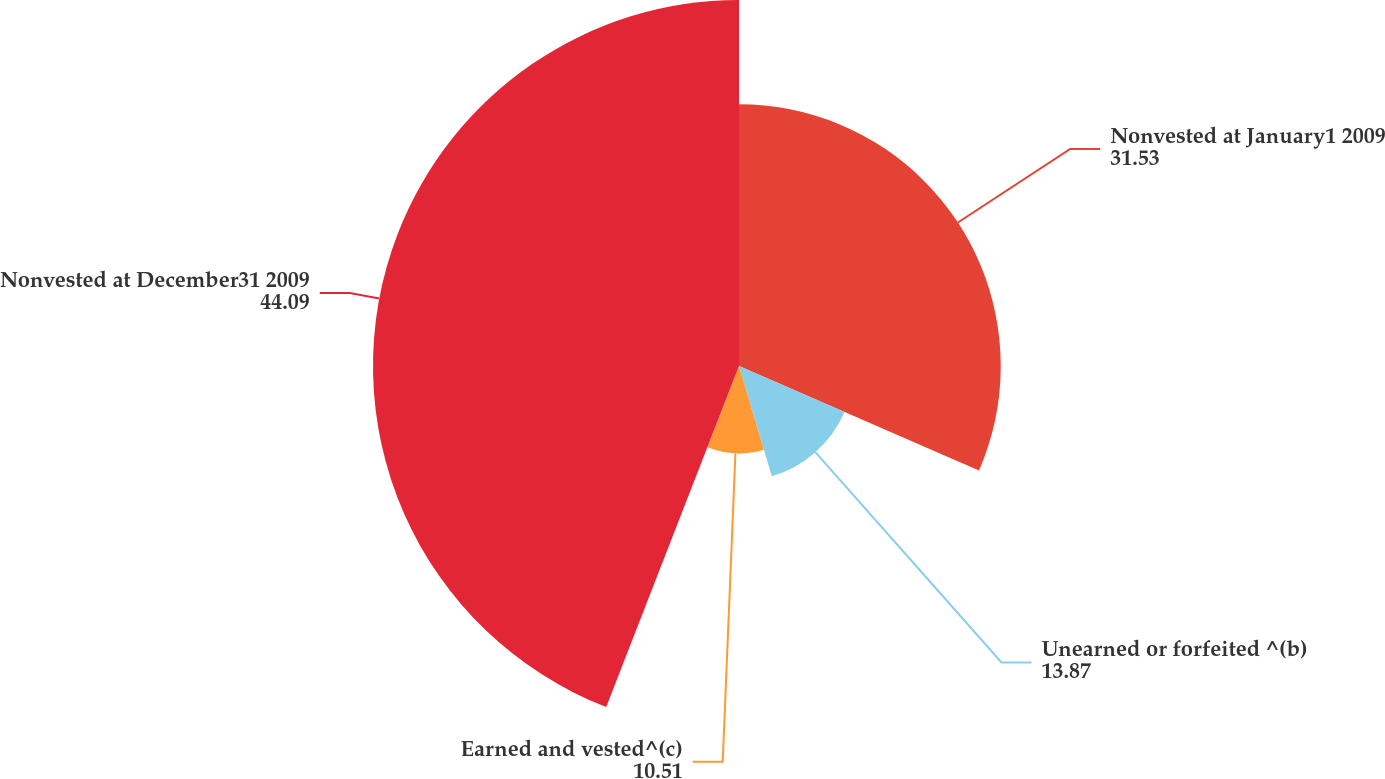Convert chart to OTSL. <chart><loc_0><loc_0><loc_500><loc_500><pie_chart><fcel>Nonvested at January1 2009<fcel>Unearned or forfeited ^(b)<fcel>Earned and vested^(c)<fcel>Nonvested at December31 2009<nl><fcel>31.53%<fcel>13.87%<fcel>10.51%<fcel>44.09%<nl></chart> 